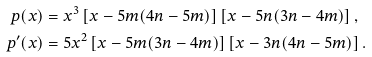<formula> <loc_0><loc_0><loc_500><loc_500>p ( x ) & = x ^ { 3 } \left [ x - 5 m ( 4 n - 5 m ) \right ] \left [ x - 5 n ( 3 n - 4 m ) \right ] , \\ p ^ { \prime } ( x ) & = 5 x ^ { 2 } \left [ x - 5 m ( 3 n - 4 m ) \right ] \left [ x - 3 n ( 4 n - 5 m ) \right ] .</formula> 